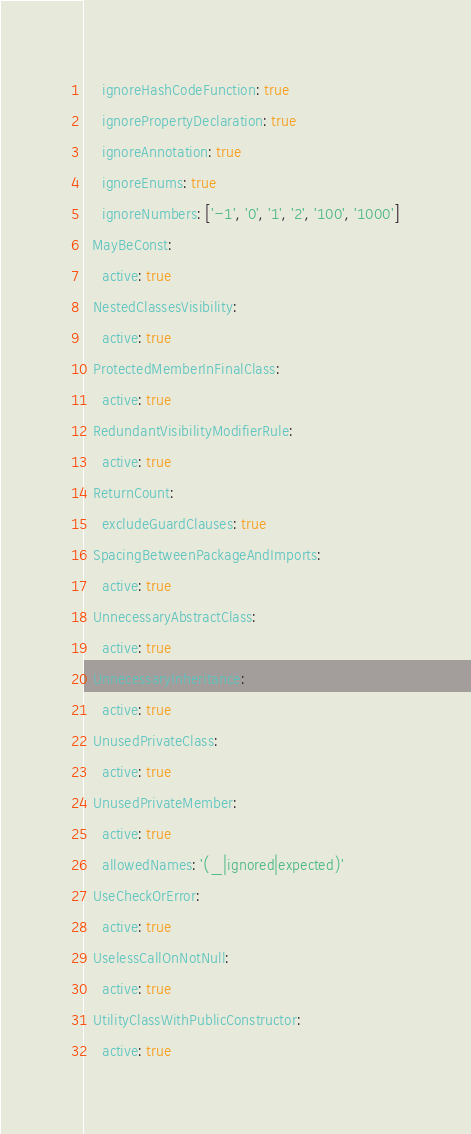Convert code to text. <code><loc_0><loc_0><loc_500><loc_500><_YAML_>    ignoreHashCodeFunction: true
    ignorePropertyDeclaration: true
    ignoreAnnotation: true
    ignoreEnums: true
    ignoreNumbers: ['-1', '0', '1', '2', '100', '1000']
  MayBeConst:
    active: true
  NestedClassesVisibility:
    active: true
  ProtectedMemberInFinalClass:
    active: true
  RedundantVisibilityModifierRule:
    active: true
  ReturnCount:
    excludeGuardClauses: true
  SpacingBetweenPackageAndImports:
    active: true
  UnnecessaryAbstractClass:
    active: true
  UnnecessaryInheritance:
    active: true
  UnusedPrivateClass:
    active: true
  UnusedPrivateMember:
    active: true
    allowedNames: '(_|ignored|expected)'
  UseCheckOrError:
    active: true
  UselessCallOnNotNull:
    active: true
  UtilityClassWithPublicConstructor:
    active: true
</code> 